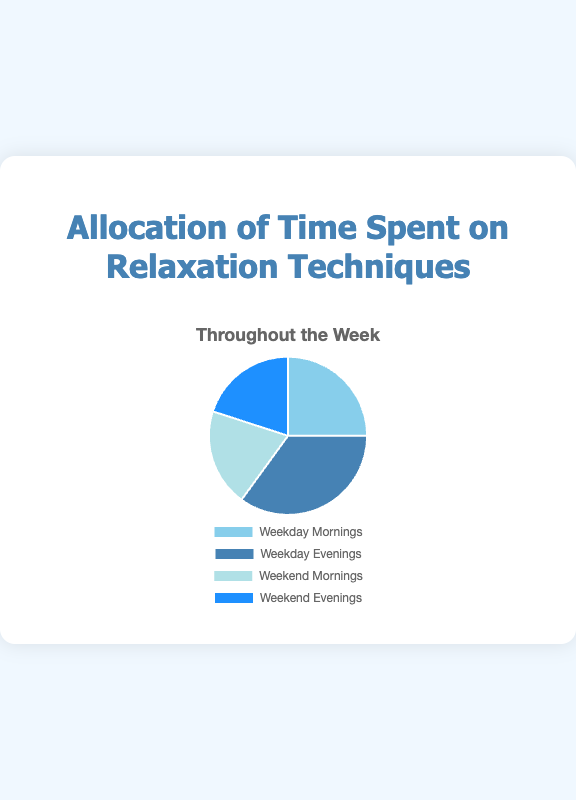What percentage of time is spent on relaxation techniques during weekday evenings? Referring to the figure, the portion allocated to 'Weekday Evenings' is clearly labeled. This label indicates that 35% of the time is spent on relaxation techniques during weekday evenings.
Answer: 35% How does the time spent on relaxation techniques during weekday mornings compare to weekend mornings? By observing the pie chart, we see that 'Weekday Mornings' account for 25%, while 'Weekend Mornings' account for 20%. Therefore, a greater percentage of time is allocated to weekday mornings compared to weekend mornings.
Answer: Weekday mornings are 5% more What is the combined percentage of the time spent on relaxation techniques during the weekends? To find the total time spent on weekends, we add the percentages for 'Weekend Mornings' and 'Weekend Evenings': 20% + 20% = 40%.
Answer: 40% Which category has the least allocation of time spent on relaxation techniques, and how much is it? The figure labels show percentages for each category, indicating that both 'Weekend Mornings' and 'Weekend Evenings' have the smallest allocation of 20% each.
Answer: Weekend Mornings and Weekend Evenings both with 20% Are the percentages for morning and evening relaxation on weekends equal? Observing the chart, we see that 'Weekend Mornings' and 'Weekend Evenings' both have a percentage allocation of 20%.
Answer: Yes What's the difference in percentage between time spent on weekday evenings and weekday mornings for relaxation techniques? Subtract the percentage of 'Weekday Mornings' from 'Weekday Evenings': 35% - 25% = 10%.
Answer: 10% What portion of the total time is spent on relaxation techniques during the mornings? Adding together the percentages of 'Weekday Mornings' and 'Weekend Mornings': 25% + 20% = 45%.
Answer: 45% Identify the color representing 'Weekend Evenings' and state the percentage. The pie chart uses a specific color for each category. The segment corresponding to 'Weekend Evenings' is colored in dark blue and represents 20%.
Answer: Dark blue, 20% How does the total percentage for weekdays compare to the total percentage for weekends? Calculate the sum for weekdays (Weekday Mornings + Weekday Evenings: 25% + 35% = 60%) and weekends (Weekend Mornings + Weekend Evenings: 20% + 20% = 40%). Comparing these values, the time spent on weekdays is 20% more than on weekends.
Answer: 20% more on weekdays What's the total percentage of time spent on relaxation techniques in the evenings? Sum the percentages for 'Weekday Evenings' and 'Weekend Evenings' (35% + 20% = 55%).
Answer: 55% 